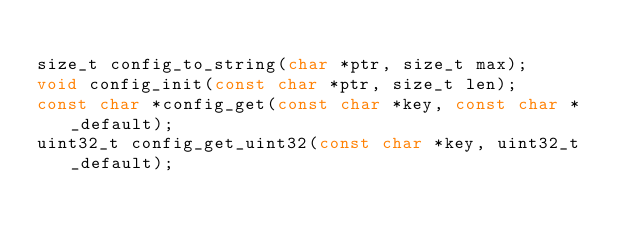<code> <loc_0><loc_0><loc_500><loc_500><_C_>
size_t config_to_string(char *ptr, size_t max);
void config_init(const char *ptr, size_t len);
const char *config_get(const char *key, const char *_default);
uint32_t config_get_uint32(const char *key, uint32_t _default);</code> 